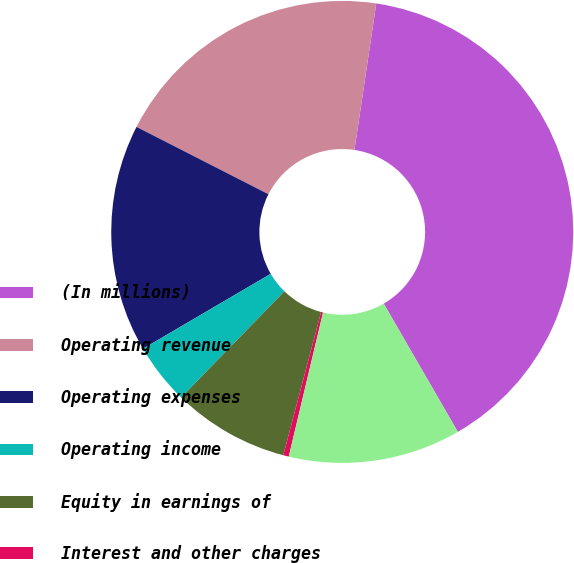Convert chart. <chart><loc_0><loc_0><loc_500><loc_500><pie_chart><fcel>(In millions)<fcel>Operating revenue<fcel>Operating expenses<fcel>Operating income<fcel>Equity in earnings of<fcel>Interest and other charges<fcel>Net income<nl><fcel>39.3%<fcel>19.84%<fcel>15.95%<fcel>4.28%<fcel>8.17%<fcel>0.39%<fcel>12.06%<nl></chart> 